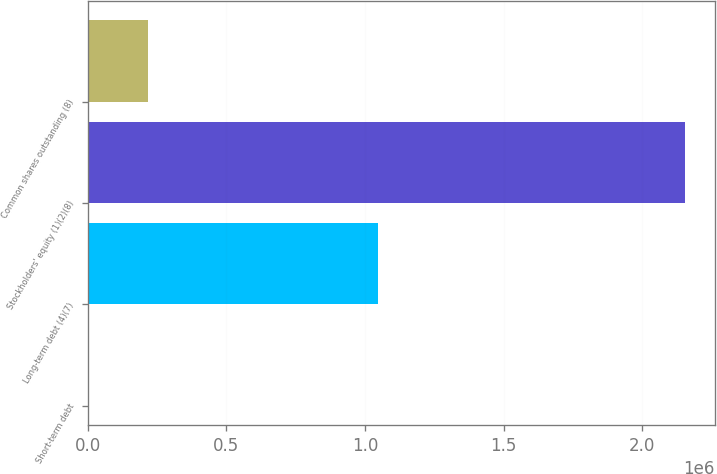Convert chart. <chart><loc_0><loc_0><loc_500><loc_500><bar_chart><fcel>Short-term debt<fcel>Long-term debt (4)(7)<fcel>Stockholders' equity (1)(2)(8)<fcel>Common shares outstanding (8)<nl><fcel>1172<fcel>1.04525e+06<fcel>2.15357e+06<fcel>216412<nl></chart> 